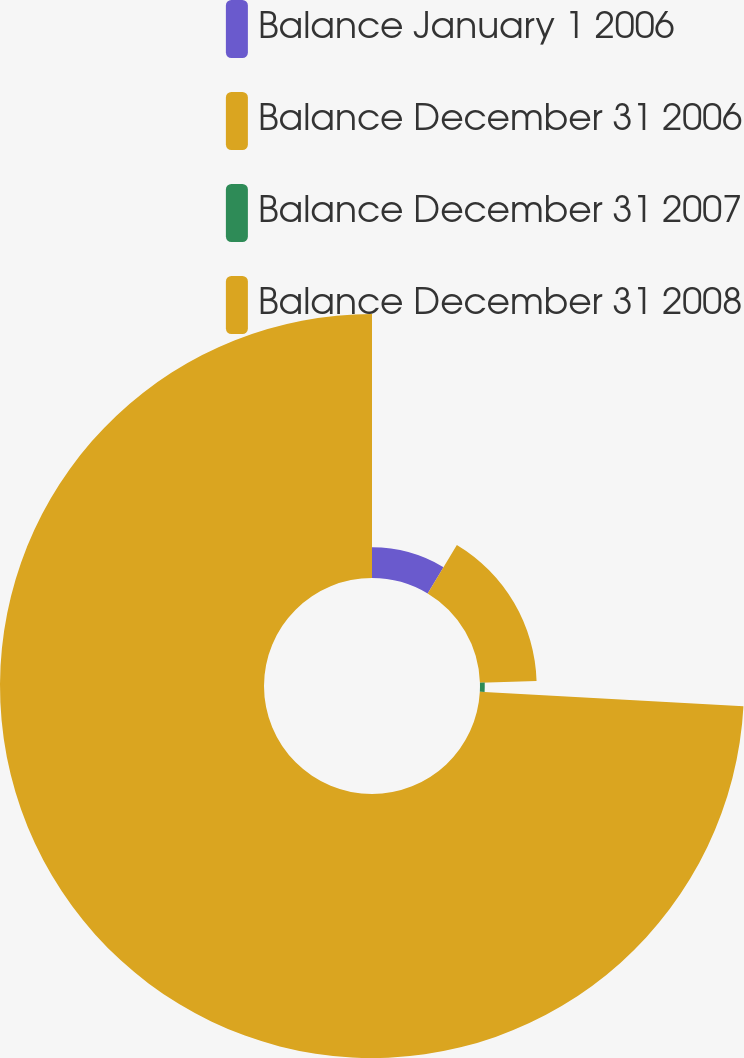Convert chart to OTSL. <chart><loc_0><loc_0><loc_500><loc_500><pie_chart><fcel>Balance January 1 2006<fcel>Balance December 31 2006<fcel>Balance December 31 2007<fcel>Balance December 31 2008<nl><fcel>8.62%<fcel>15.9%<fcel>1.34%<fcel>74.13%<nl></chart> 